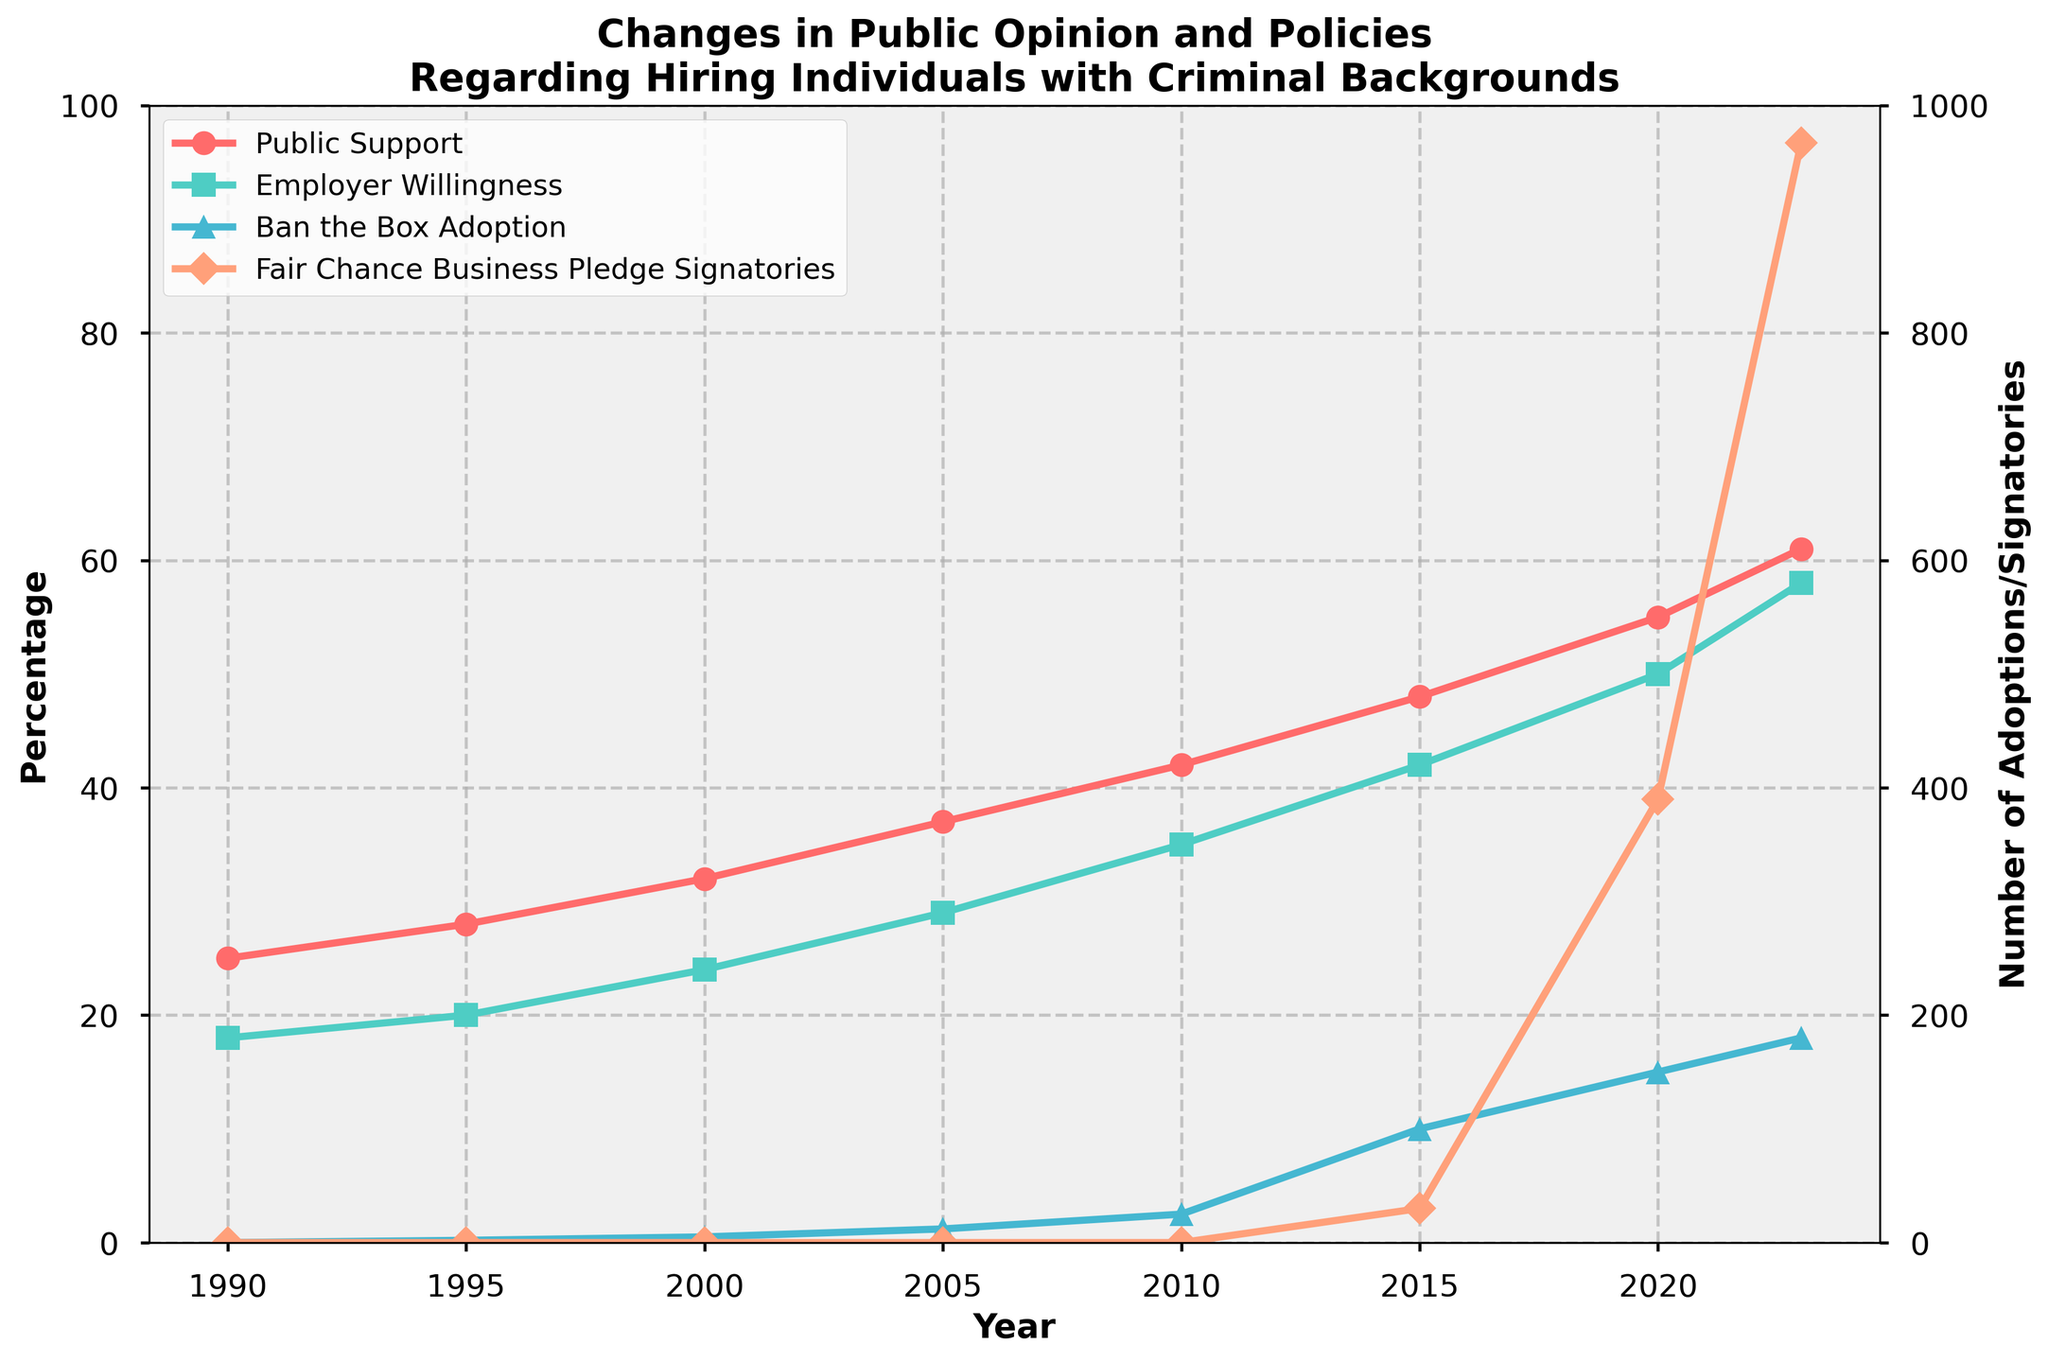What is the increase in public support for hiring individuals with criminal backgrounds from 1990 to 2023? The support percentage in 1990 was 25%, and in 2023 it was 61%. The increase can be calculated by subtracting 25 from 61.
Answer: 36% From 1990 to 2023, by how much has the employer willingness to hire individuals with criminal backgrounds increased? The willingness percentage in 1990 was 18%, and in 2023 it was 58%. The increase can be calculated by subtracting 18 from 58.
Answer: 40% What is the relationship between public support and employer willingness to hire individuals with criminal backgrounds in 2020? In the chart, we observe the values for both public support and employer willingness in 2020. Public support is at 55%, while employer willingness is at 50%. Both metrics are relatively close but public support is slightly higher.
Answer: Public support is higher Which year shows the sharpest increase in the number of Ban the Box adoptions? Looking at the line for Ban the Box Adoption, the most significant increase is between 2010 and 2015, where the count jumps from 25 to 100.
Answer: 2010 to 2015 How does the number of Fair Chance Business Pledge signatories compare between 2015 and 2023? From the chart, in 2015, there were 30 signatories, whereas in 2023, there were 967 signatories. To find the difference, subtract 30 from 967.
Answer: 937 more signatories in 2023 What is the average percentage increase in employer willingness over each decade? The values for employer willingness in each decade are 18% (1990), 29% (2005), 42% (2015), and 58% (2023). The differences are 11% (1990-2005), 13% (2005-2015), and 16% (2015-2023). To find the average, sum these differences and divide by 3: (11 + 13 + 16) / 3.
Answer: 13.33% What trend can be observed in the public support data from 1990 to 2023? By looking at the public support line, we see a consistent upward trend from 1990 to 2023 with no dips.
Answer: Upward trend Which line represents the highest value in 2023? Observing all the lines in 2023, the line for Fair Chance Business Pledge Signatories surpasses all others, ending at 967.
Answer: Fair Chance Business Pledge Signatories Is there a correlation between the number of Ban the Box adoptions and employer willingness? Looking at the lines for Ban the Box adoptions and employer willingness, both show an increasing trend over the years, but they must be further analyzed to determine a statistical correlation.
Answer: Positive correlated trend 